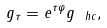<formula> <loc_0><loc_0><loc_500><loc_500>g _ { \tau } = e ^ { \tau \varphi } g _ { \ h c } ,</formula> 